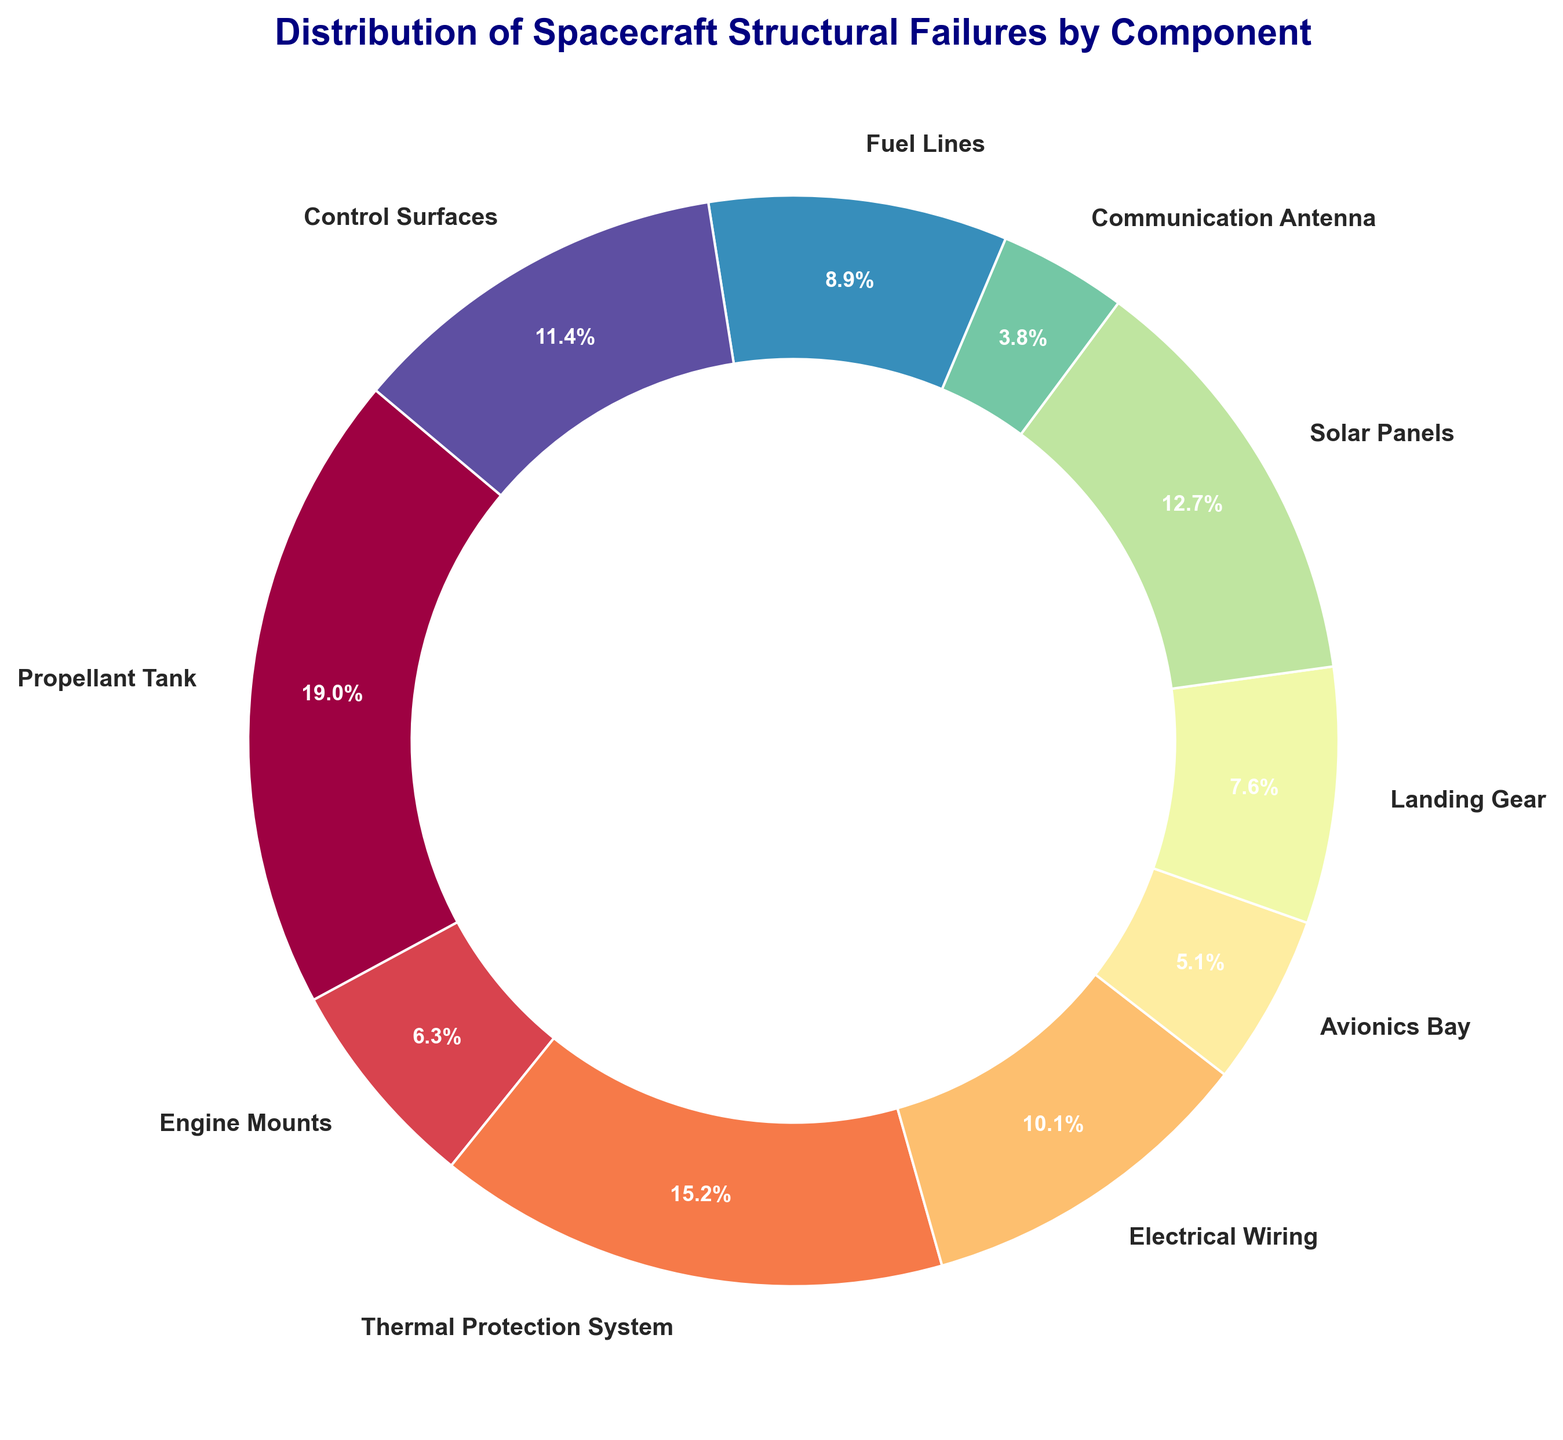Which component has the highest percentage of structural failures? By looking at the pie chart, the section with the largest percentage value represents the component with the highest percentage of failures. In this case, it is the "Propellant Tank" section.
Answer: Propellant Tank What is the combined percentage of failures for Solar Panels and Control Surfaces? Identify the percentages for Solar Panels and Control Surfaces from the chart. Solar Panels have 11.5% and Control Surfaces have 10.3%. Sum these percentages to get the combined value: 11.5% + 10.3% = 21.8%.
Answer: 21.8% Which component has fewer failures, the Engine Mounts or the Avionics Bay? Check the percentages represented for Engine Mounts and Avionics Bay on the pie chart. Engine Mounts have 6.4% and Avionics Bay has 5.6%. Since 5.6% is less than 6.4%, Avionics Bay has fewer failures.
Answer: Avionics Bay What is the percentage of failures represented by the components related to fuel (Propellant Tank and Fuel Lines)? First, find the percentages for Propellant Tank (19.2%) and Fuel Lines (9.0%) in the chart. Sum these percentages: 19.2% + 9.0% = 28.2%.
Answer: 28.2% Which component's failure percentage is closest to the average failure percentage of all components presented? First, calculate the average percentage by summing all presented percentages and dividing by the number of components: (19.2 + 6.4 + 15.4 + 10.3 + 5.1 + 7.7 + 12.8 + 3.8 + 9.0 + 11.5) / 10 = 10.12%. The component whose failure percentage is closest to 10.12% is Electrical Wiring with 10.3%.
Answer: Electrical Wiring Compare the failure percentages between the Thermal Protection System and the Electrical Wiring components. Which one has a higher failure rate? Identify the percentages from the chart for both components. The Thermal Protection System has 15.4%, while Electrical Wiring has 10.3%. Since 15.4% is greater than 10.3%, Thermal Protection System has a higher failure rate.
Answer: Thermal Protection System What is the total count of failures for Communication Antenna and Landing Gear, and what percentage does that represent? Find the failure counts for both components: Communication Antenna has 3 and Landing Gear has 6. Total count of failures is 3 + 6 = 9. To find the percentage, sum the total failures of all components: 15 + 5 + 12 + 8 + 4 + 6 + 10 + 3 + 7 + 9 = 79. The percentage is (9 / 79) * 100 ≈ 11.4%.
Answer: 11.4% Which component has a larger slice visually, Solar Panels or Fuel Lines? Look at the pie chart and compare the sizes of the slices representing Solar Panels and Fuel Lines. Solar Panels have 12.8%, while Fuel Lines have 9.0%. Since 12.8% is greater, Solar Panels have a larger slice.
Answer: Solar Panels 